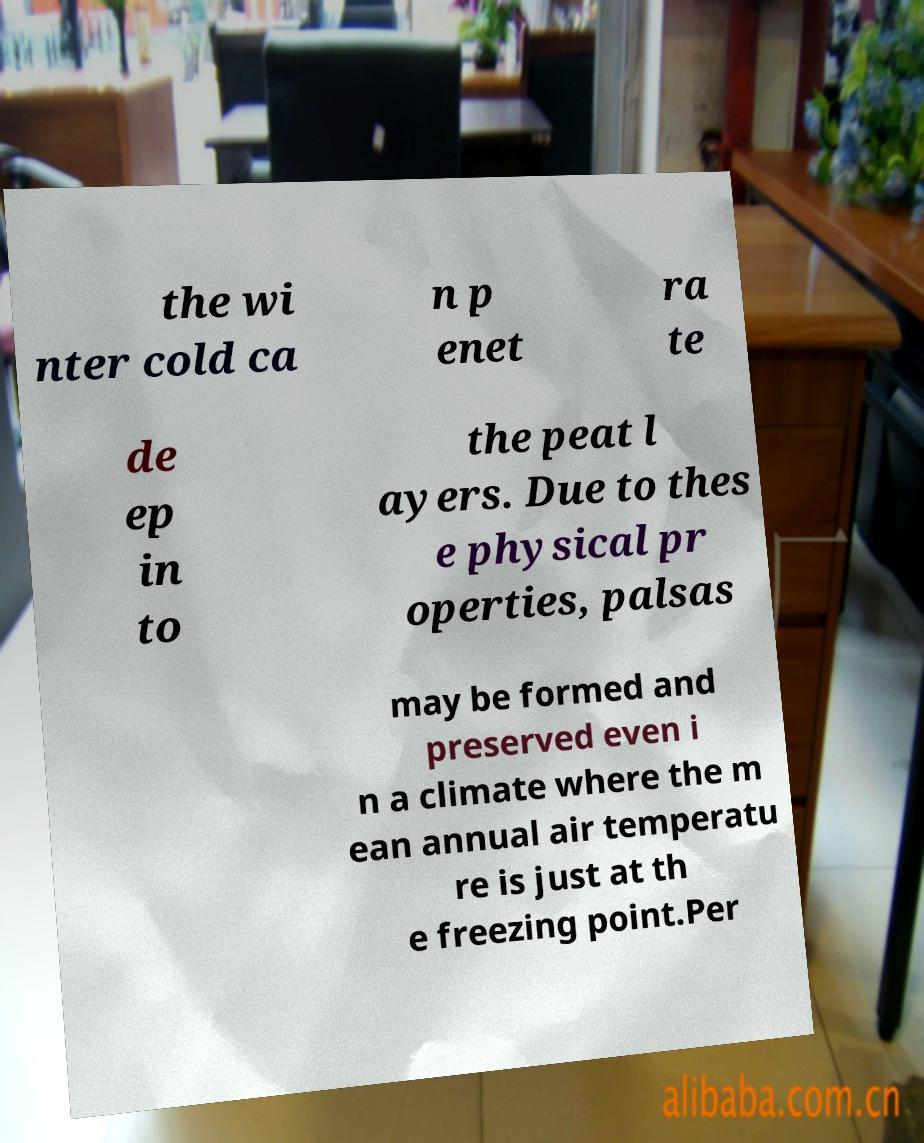Can you accurately transcribe the text from the provided image for me? the wi nter cold ca n p enet ra te de ep in to the peat l ayers. Due to thes e physical pr operties, palsas may be formed and preserved even i n a climate where the m ean annual air temperatu re is just at th e freezing point.Per 